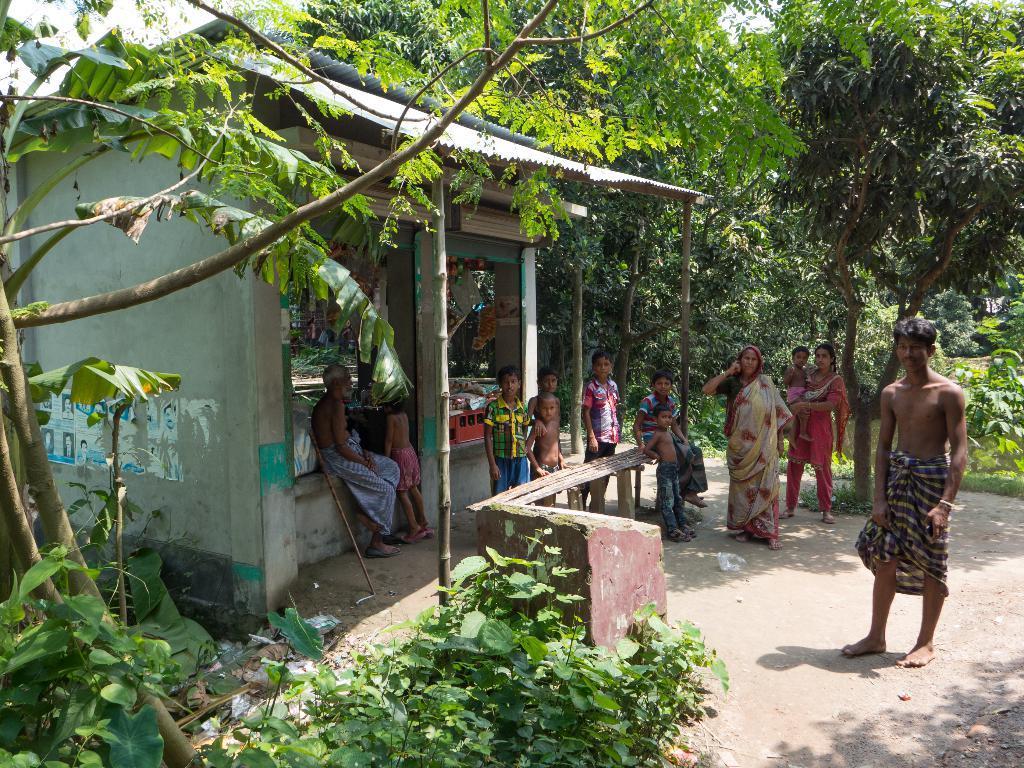Can you describe this image briefly? In this picture we can see a group of men and women with small children, standing in the front and looking to the camera. Behind we can see the shops and some trees in the background. 